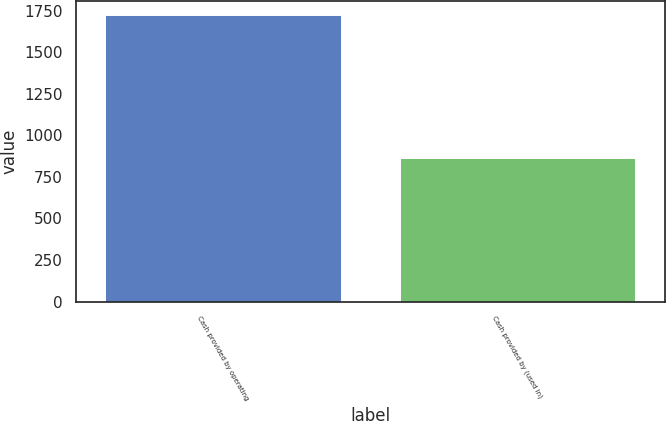Convert chart. <chart><loc_0><loc_0><loc_500><loc_500><bar_chart><fcel>Cash provided by operating<fcel>Cash provided by (used in)<nl><fcel>1723<fcel>862<nl></chart> 